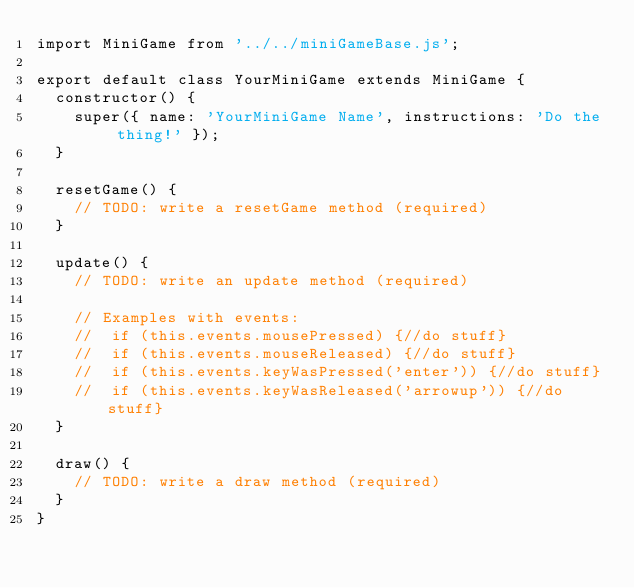Convert code to text. <code><loc_0><loc_0><loc_500><loc_500><_JavaScript_>import MiniGame from '../../miniGameBase.js';

export default class YourMiniGame extends MiniGame {
  constructor() {
    super({ name: 'YourMiniGame Name', instructions: 'Do the thing!' });
  }

  resetGame() {
    // TODO: write a resetGame method (required)
  }

  update() {
    // TODO: write an update method (required)

    // Examples with events:
    //  if (this.events.mousePressed) {//do stuff}
    //  if (this.events.mouseReleased) {//do stuff}
    //  if (this.events.keyWasPressed('enter')) {//do stuff}
    //  if (this.events.keyWasReleased('arrowup')) {//do stuff}
  }

  draw() {
    // TODO: write a draw method (required)
  }
}
</code> 